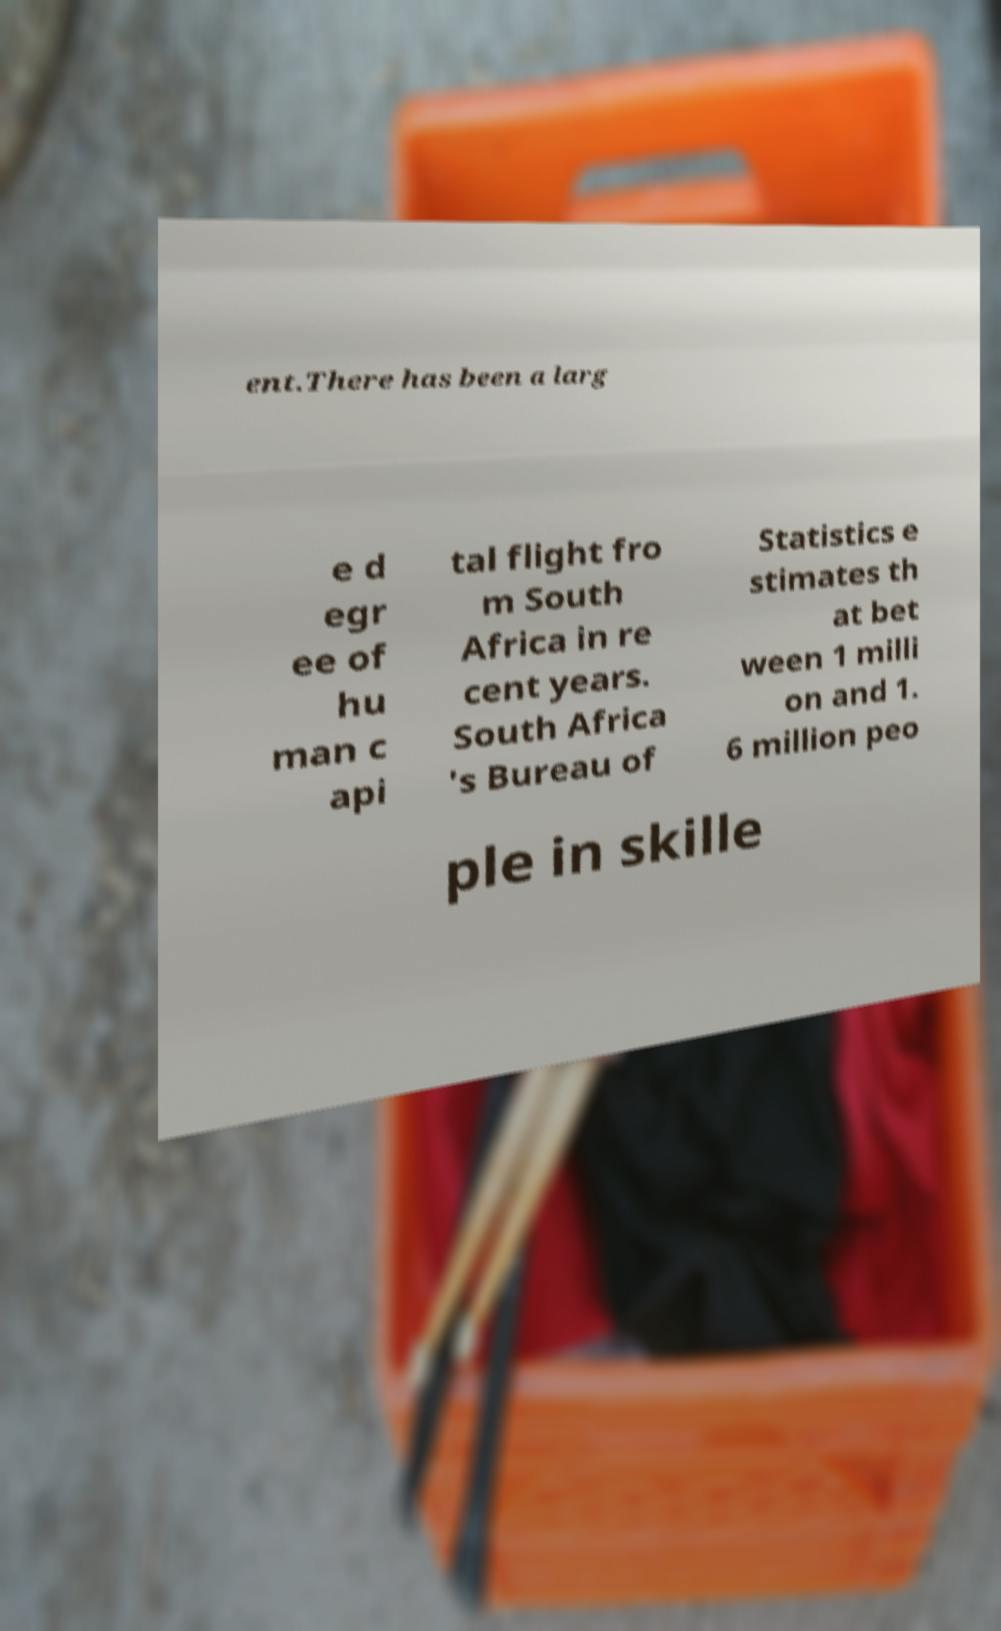Could you extract and type out the text from this image? ent.There has been a larg e d egr ee of hu man c api tal flight fro m South Africa in re cent years. South Africa 's Bureau of Statistics e stimates th at bet ween 1 milli on and 1. 6 million peo ple in skille 